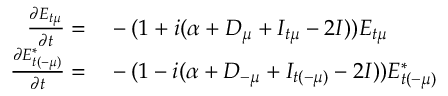<formula> <loc_0><loc_0><loc_500><loc_500>\begin{array} { r l } { \frac { \partial E _ { t \mu } } { \partial t } = } & - ( 1 + i ( \alpha + D _ { \mu } + I _ { t \mu } - 2 I ) ) E _ { t \mu } } \\ { \frac { \partial E _ { t ( - \mu ) } ^ { * } } { \partial t } = } & - ( 1 - i ( \alpha + D _ { - \mu } + I _ { t ( - \mu ) } - 2 I ) ) E _ { t ( - \mu ) } ^ { * } } \end{array}</formula> 